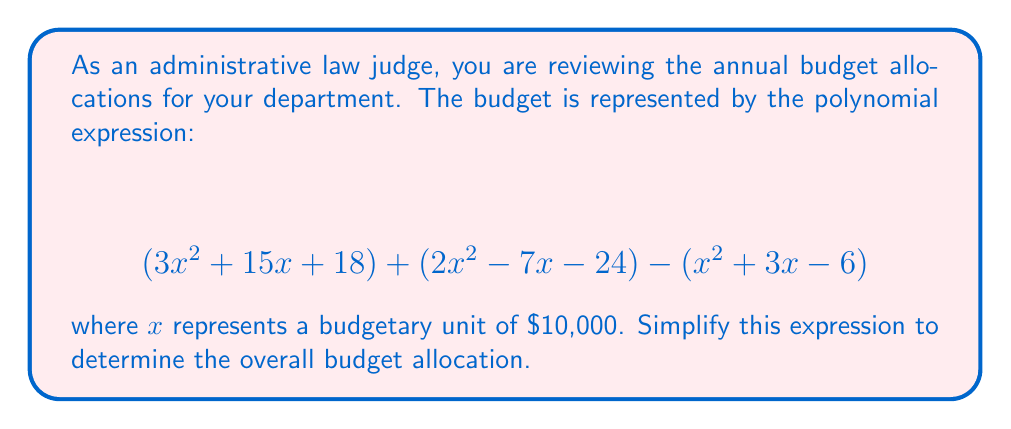What is the answer to this math problem? To simplify this polynomial expression, we need to combine like terms:

1) First, let's group the terms with the same degree:

   $$(3x^2 + 2x^2 - x^2) + (15x - 7x - 3x) + (18 - 24 + 6)$$

2) Now, let's simplify each group:

   For $x^2$ terms: $3x^2 + 2x^2 - x^2 = 4x^2$
   For $x$ terms: $15x - 7x - 3x = 5x$
   For constant terms: $18 - 24 + 6 = 0$

3) Combining these simplified terms:

   $$4x^2 + 5x + 0$$

4) Since adding zero doesn't change the value, we can omit it:

   $$4x^2 + 5x$$

This is the simplified form of the polynomial expression representing the budget allocation.
Answer: $4x^2 + 5x$ 